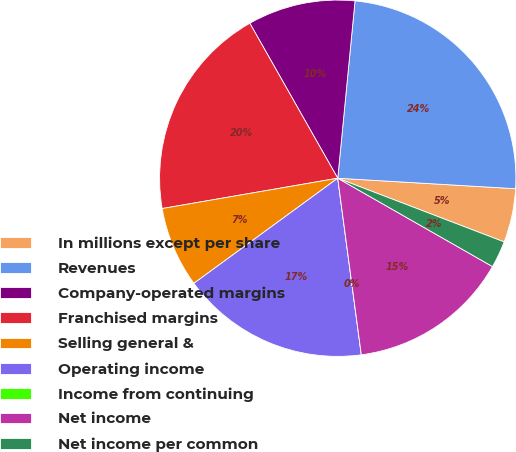Convert chart to OTSL. <chart><loc_0><loc_0><loc_500><loc_500><pie_chart><fcel>In millions except per share<fcel>Revenues<fcel>Company-operated margins<fcel>Franchised margins<fcel>Selling general &<fcel>Operating income<fcel>Income from continuing<fcel>Net income<fcel>Net income per common<nl><fcel>4.88%<fcel>24.39%<fcel>9.76%<fcel>19.51%<fcel>7.32%<fcel>17.07%<fcel>0.0%<fcel>14.63%<fcel>2.44%<nl></chart> 